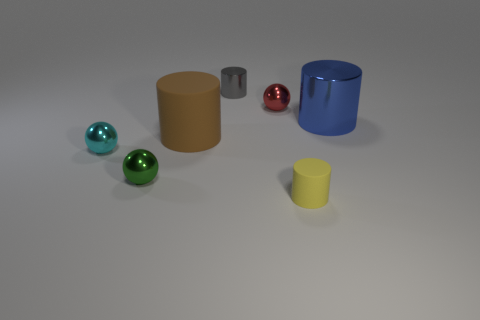Subtract all cyan shiny balls. How many balls are left? 2 Add 1 green rubber objects. How many objects exist? 8 Subtract all yellow cylinders. How many cylinders are left? 3 Add 4 cyan objects. How many cyan objects are left? 5 Add 3 red balls. How many red balls exist? 4 Subtract 0 brown spheres. How many objects are left? 7 Subtract all balls. How many objects are left? 4 Subtract 1 balls. How many balls are left? 2 Subtract all red balls. Subtract all cyan cylinders. How many balls are left? 2 Subtract all gray balls. How many blue cylinders are left? 1 